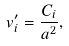Convert formula to latex. <formula><loc_0><loc_0><loc_500><loc_500>v _ { i } ^ { \prime } = \frac { C _ { i } } { a ^ { 2 } } ,</formula> 